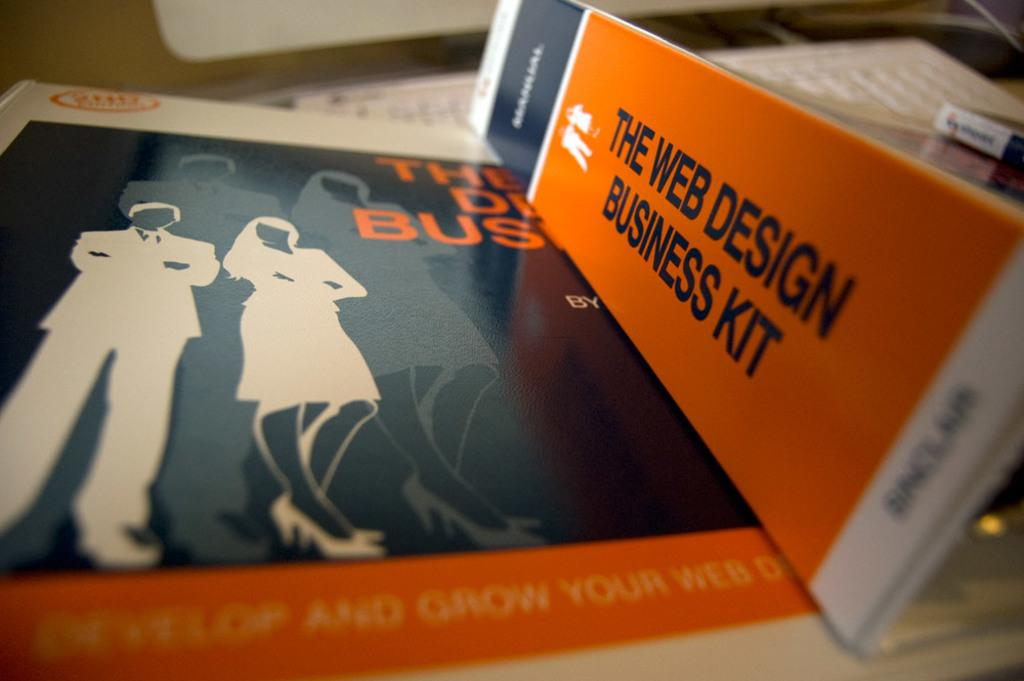<image>
Write a terse but informative summary of the picture. The kit shown here is a kit for Business design. 